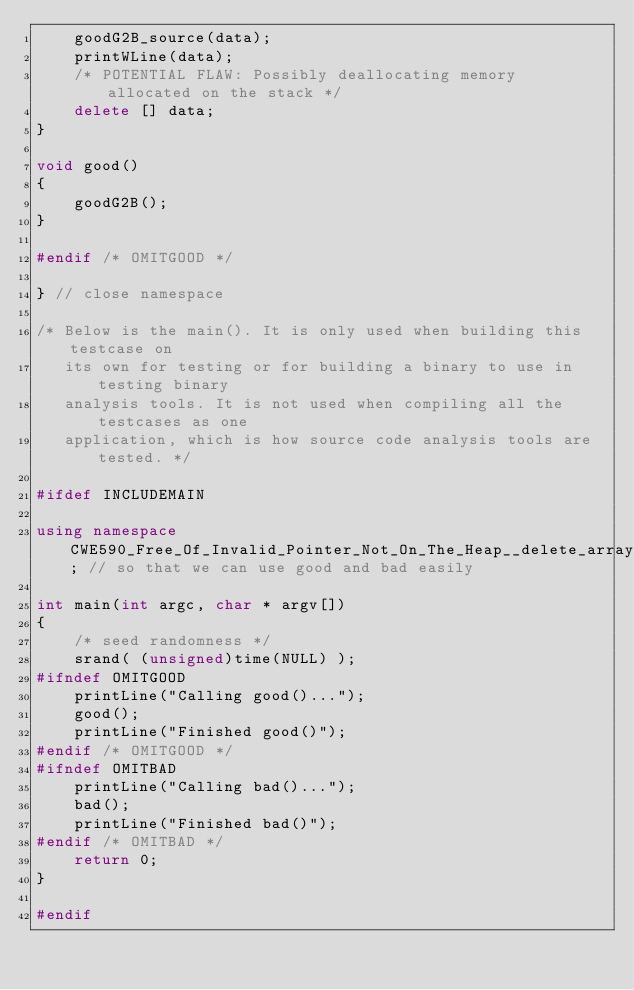Convert code to text. <code><loc_0><loc_0><loc_500><loc_500><_C++_>    goodG2B_source(data);
    printWLine(data);
    /* POTENTIAL FLAW: Possibly deallocating memory allocated on the stack */
    delete [] data;
}

void good()
{
    goodG2B();
}

#endif /* OMITGOOD */

} // close namespace

/* Below is the main(). It is only used when building this testcase on
   its own for testing or for building a binary to use in testing binary
   analysis tools. It is not used when compiling all the testcases as one
   application, which is how source code analysis tools are tested. */

#ifdef INCLUDEMAIN

using namespace CWE590_Free_Of_Invalid_Pointer_Not_On_The_Heap__delete_array_wchar_t_static_62; // so that we can use good and bad easily

int main(int argc, char * argv[])
{
    /* seed randomness */
    srand( (unsigned)time(NULL) );
#ifndef OMITGOOD
    printLine("Calling good()...");
    good();
    printLine("Finished good()");
#endif /* OMITGOOD */
#ifndef OMITBAD
    printLine("Calling bad()...");
    bad();
    printLine("Finished bad()");
#endif /* OMITBAD */
    return 0;
}

#endif
</code> 